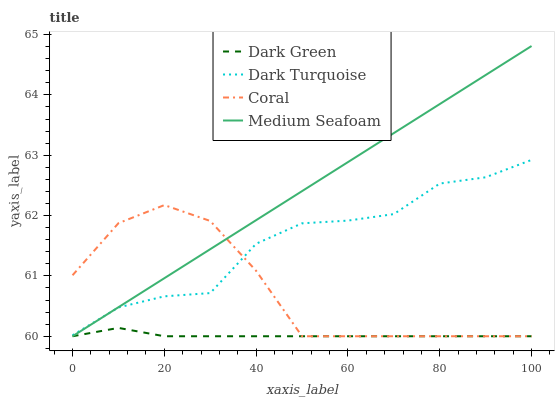Does Dark Green have the minimum area under the curve?
Answer yes or no. Yes. Does Medium Seafoam have the maximum area under the curve?
Answer yes or no. Yes. Does Coral have the minimum area under the curve?
Answer yes or no. No. Does Coral have the maximum area under the curve?
Answer yes or no. No. Is Medium Seafoam the smoothest?
Answer yes or no. Yes. Is Coral the roughest?
Answer yes or no. Yes. Is Coral the smoothest?
Answer yes or no. No. Is Medium Seafoam the roughest?
Answer yes or no. No. Does Coral have the lowest value?
Answer yes or no. Yes. Does Medium Seafoam have the highest value?
Answer yes or no. Yes. Does Coral have the highest value?
Answer yes or no. No. Is Dark Green less than Dark Turquoise?
Answer yes or no. Yes. Is Dark Turquoise greater than Dark Green?
Answer yes or no. Yes. Does Coral intersect Medium Seafoam?
Answer yes or no. Yes. Is Coral less than Medium Seafoam?
Answer yes or no. No. Is Coral greater than Medium Seafoam?
Answer yes or no. No. Does Dark Green intersect Dark Turquoise?
Answer yes or no. No. 